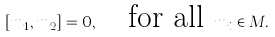Convert formula to latex. <formula><loc_0><loc_0><loc_500><loc_500>[ m _ { 1 } , m _ { 2 } ] = 0 , \quad \text {for all } m _ { i } \in M .</formula> 